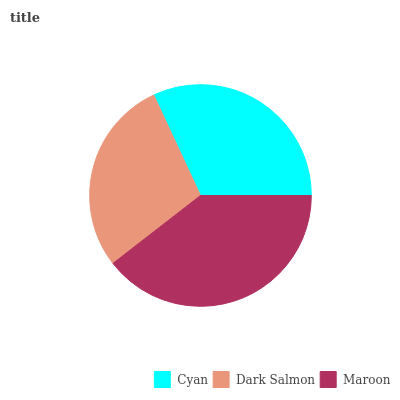Is Dark Salmon the minimum?
Answer yes or no. Yes. Is Maroon the maximum?
Answer yes or no. Yes. Is Maroon the minimum?
Answer yes or no. No. Is Dark Salmon the maximum?
Answer yes or no. No. Is Maroon greater than Dark Salmon?
Answer yes or no. Yes. Is Dark Salmon less than Maroon?
Answer yes or no. Yes. Is Dark Salmon greater than Maroon?
Answer yes or no. No. Is Maroon less than Dark Salmon?
Answer yes or no. No. Is Cyan the high median?
Answer yes or no. Yes. Is Cyan the low median?
Answer yes or no. Yes. Is Dark Salmon the high median?
Answer yes or no. No. Is Maroon the low median?
Answer yes or no. No. 